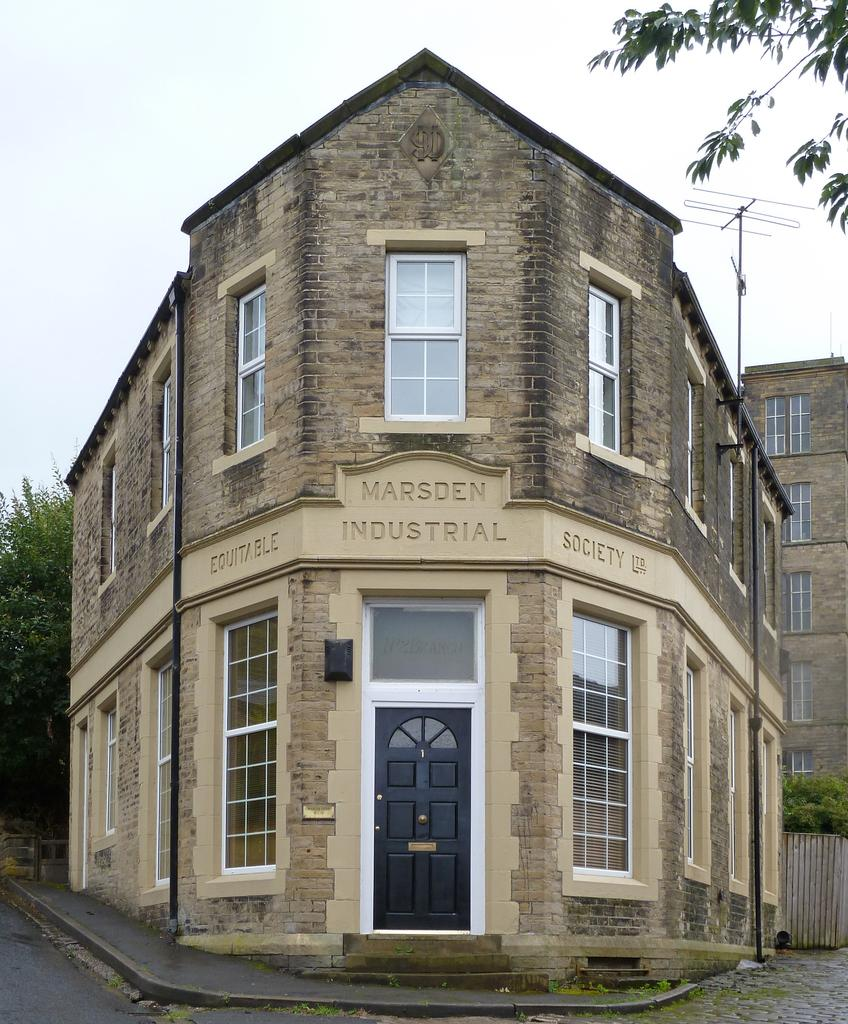What is the color of the building in the image? The building in the image is brown. What is the color of the door in the image? The door in the image is black. What can be seen in the background of the image? There are trees and the sky visible in the background of the image. What type of tax is being discussed in the image? There is no discussion of tax in the image; it features a brown building with a black door and a background with trees and the sky. 